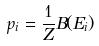Convert formula to latex. <formula><loc_0><loc_0><loc_500><loc_500>p _ { i } = \frac { 1 } { Z } B ( E _ { i } )</formula> 